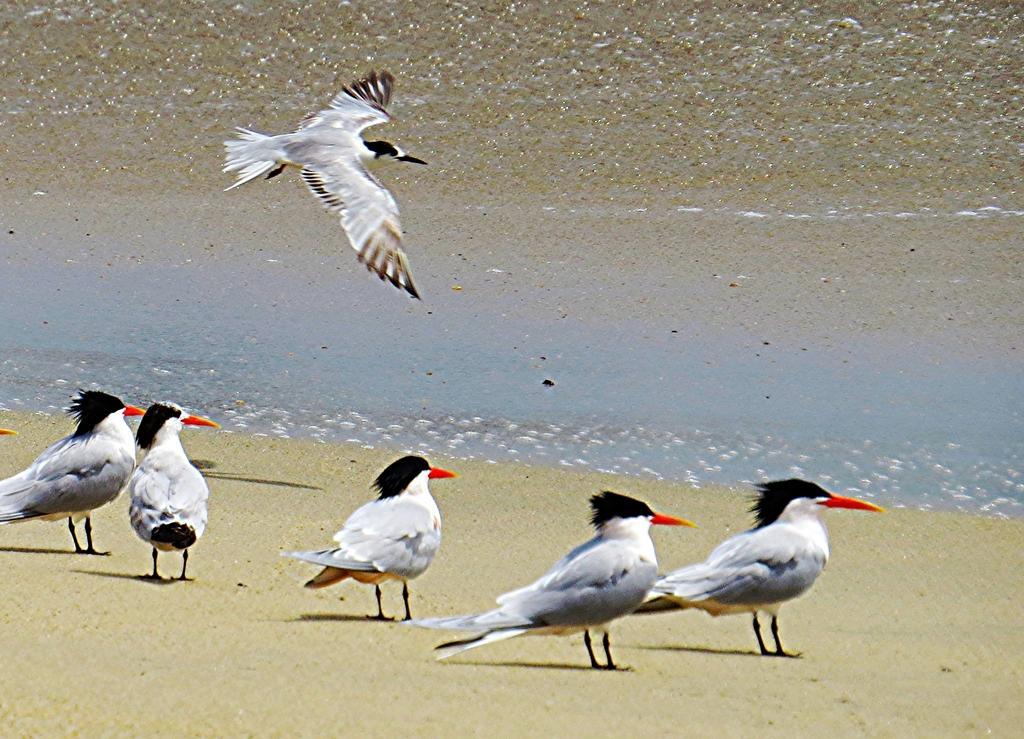Could you give a brief overview of what you see in this image? In this picture we can see a group of birds where some are standing on the ground and a bird is flying in the air. 